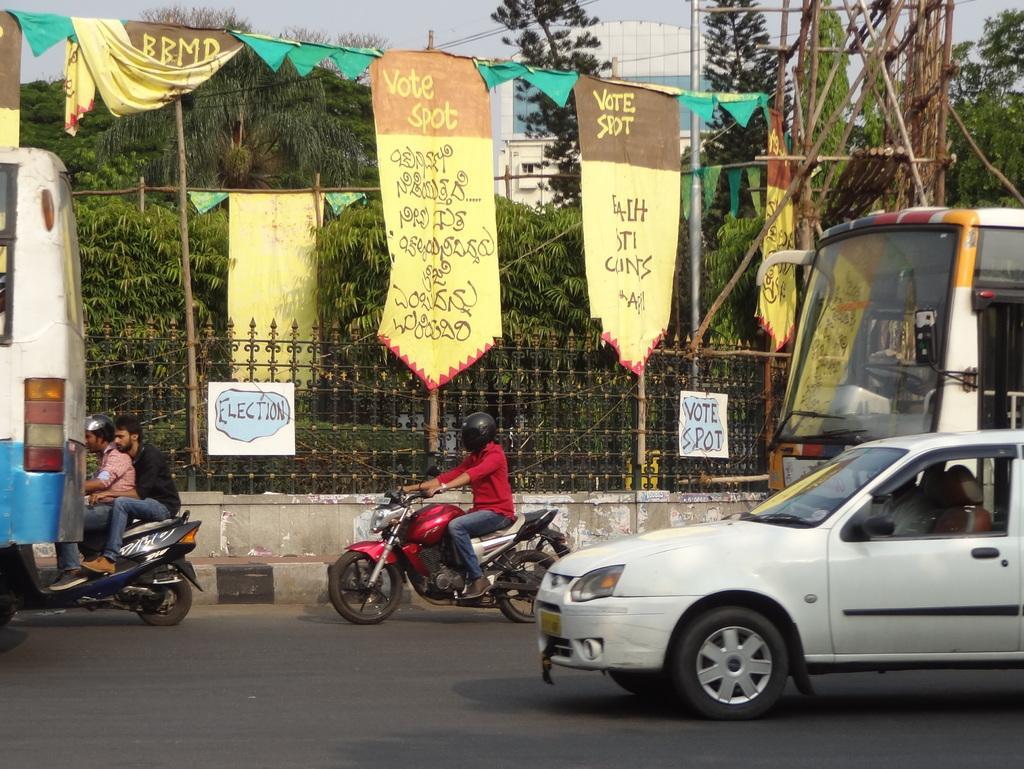Please provide a concise description of this image. In the center of the image we can see a few vehicles on the road and we can see one person in the car. And we can see two people are riding bikes, in which we can see one person is sitting beside the other person on the front bike. Among them, we can see two persons are wearing helmets. In the background we can see the sky, one building, poles, fences, trees, banners and a few other objects. On the banners, we can see some text. 